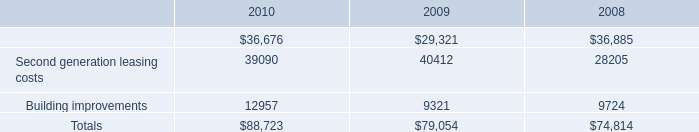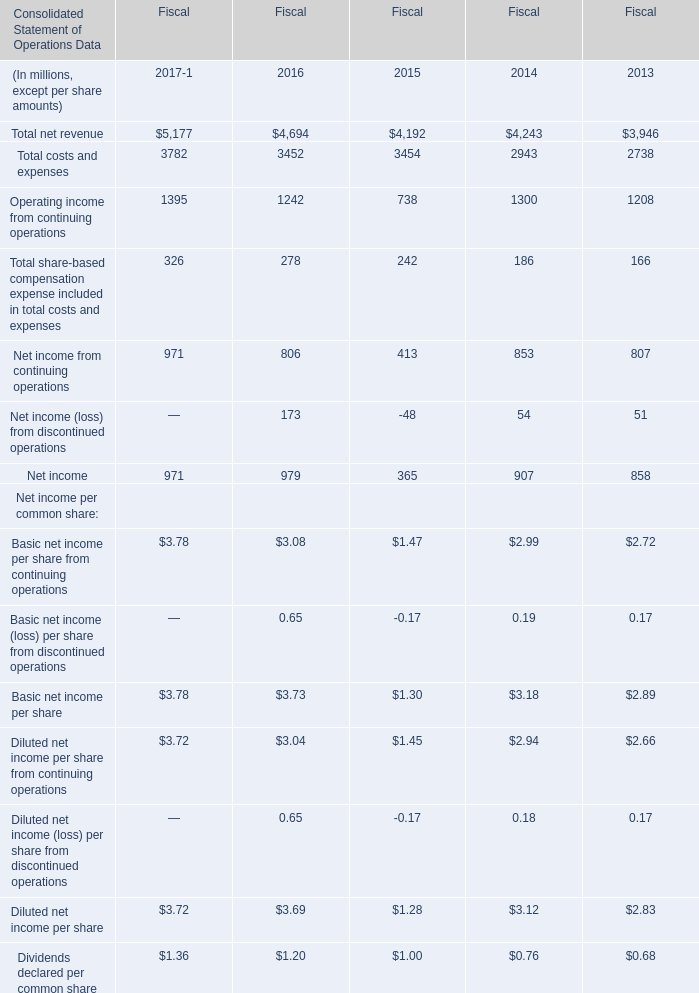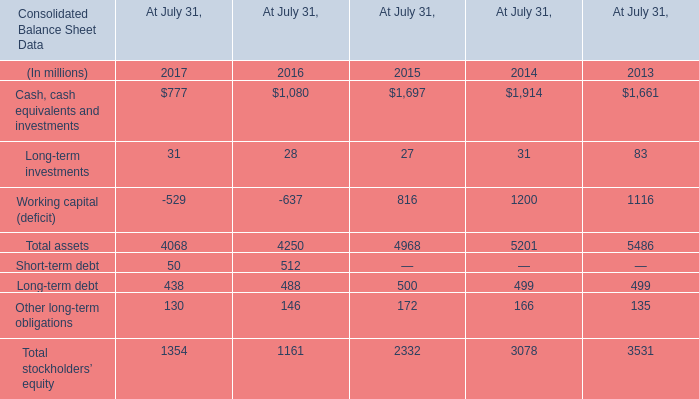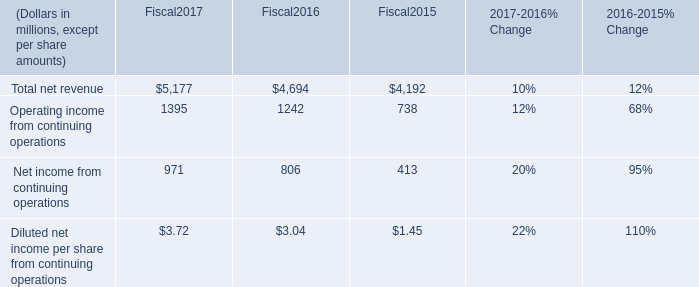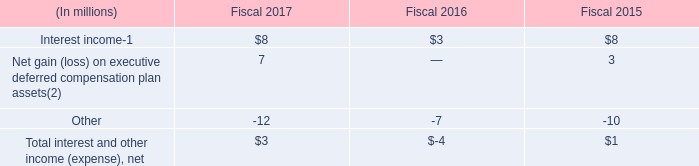What's the sum of Cash, cash equivalents and investments of At July 31, 2014, Building improvements of 2010, and Building improvements of 2008 ? 
Computations: ((1914.0 + 12957.0) + 9724.0)
Answer: 24595.0. 